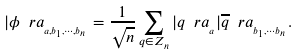<formula> <loc_0><loc_0><loc_500><loc_500>| \phi \ r a _ { _ { a , b _ { 1 } , \cdots , b _ { n } } } = \frac { 1 } { \sqrt { n } } \sum _ { q \in Z _ { n } } | q \ r a _ { _ { a } } | \overline { q } \ r a _ { _ { b _ { 1 } , \cdots b _ { n } } } .</formula> 